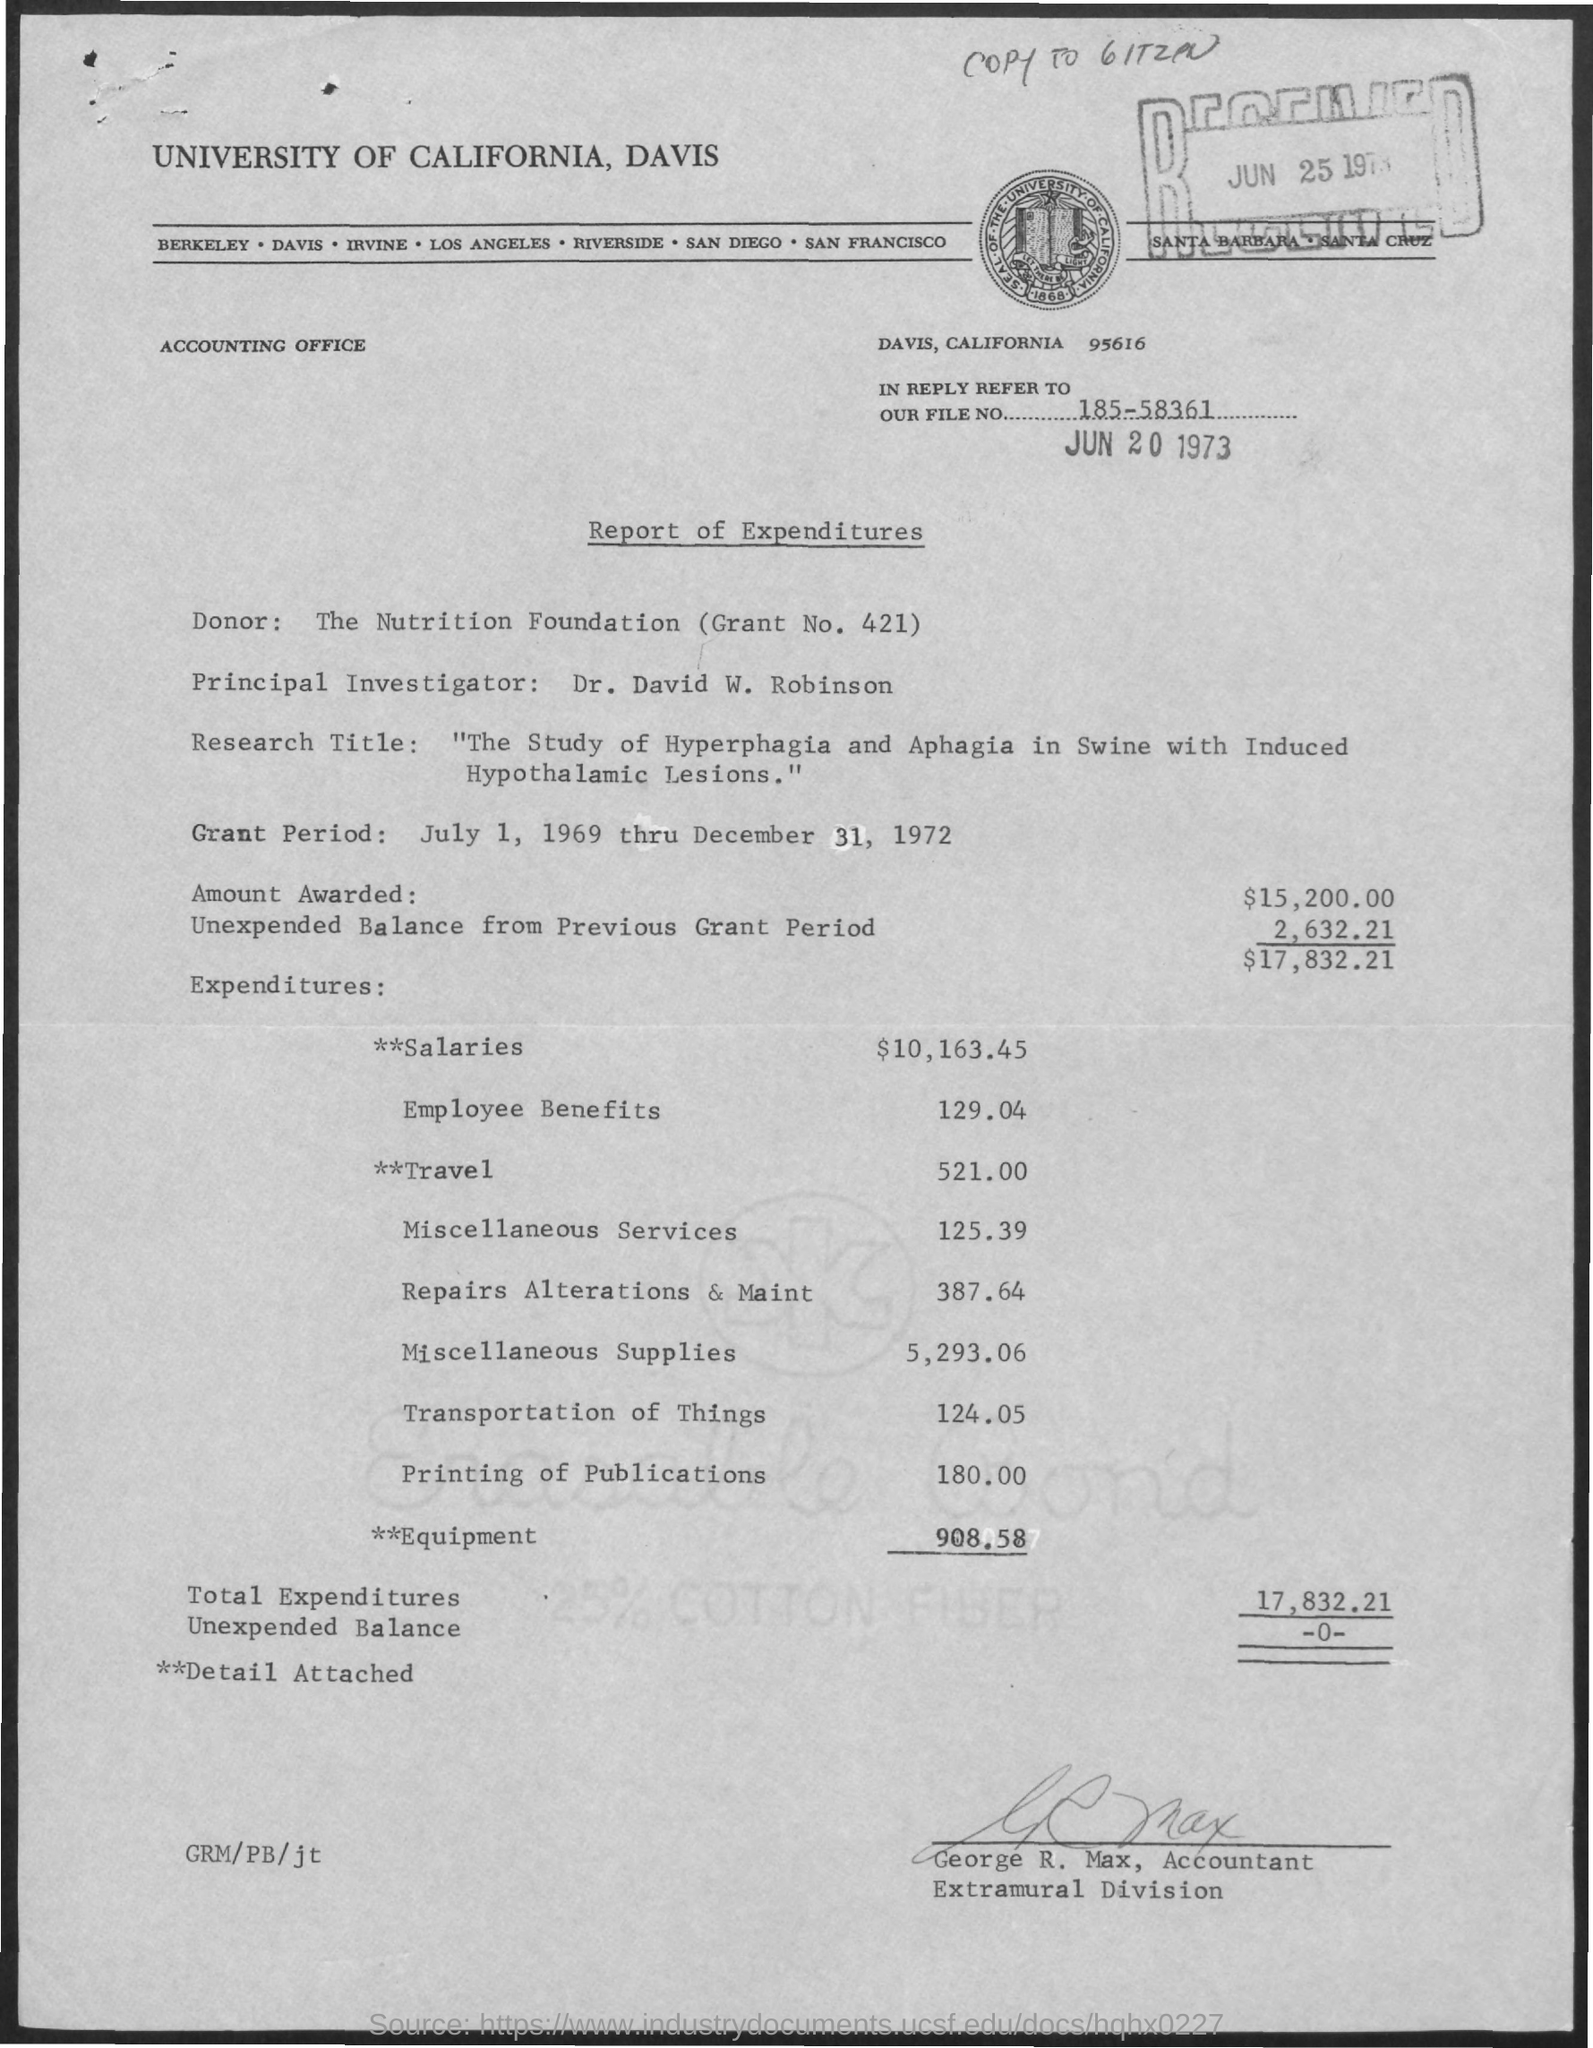What is the File No.?
Your response must be concise. 185-58361. Who is the Donor?
Provide a short and direct response. The Nutrition Foundation (Grant No. 421). Who is the Principal Investigator?
Your response must be concise. Dr. David W. Robinson. What is the Grant Period?
Your response must be concise. July 1, 1969 thru December 31, 1972. What is the Amount awarded?
Provide a short and direct response. $15,200.00. What is the Total Expenditures?
Give a very brief answer. 17,832.21. What is the Unexpended Balance?
Your answer should be very brief. -0-. What is the Title of the document?
Offer a very short reply. Report of Expenditures. 